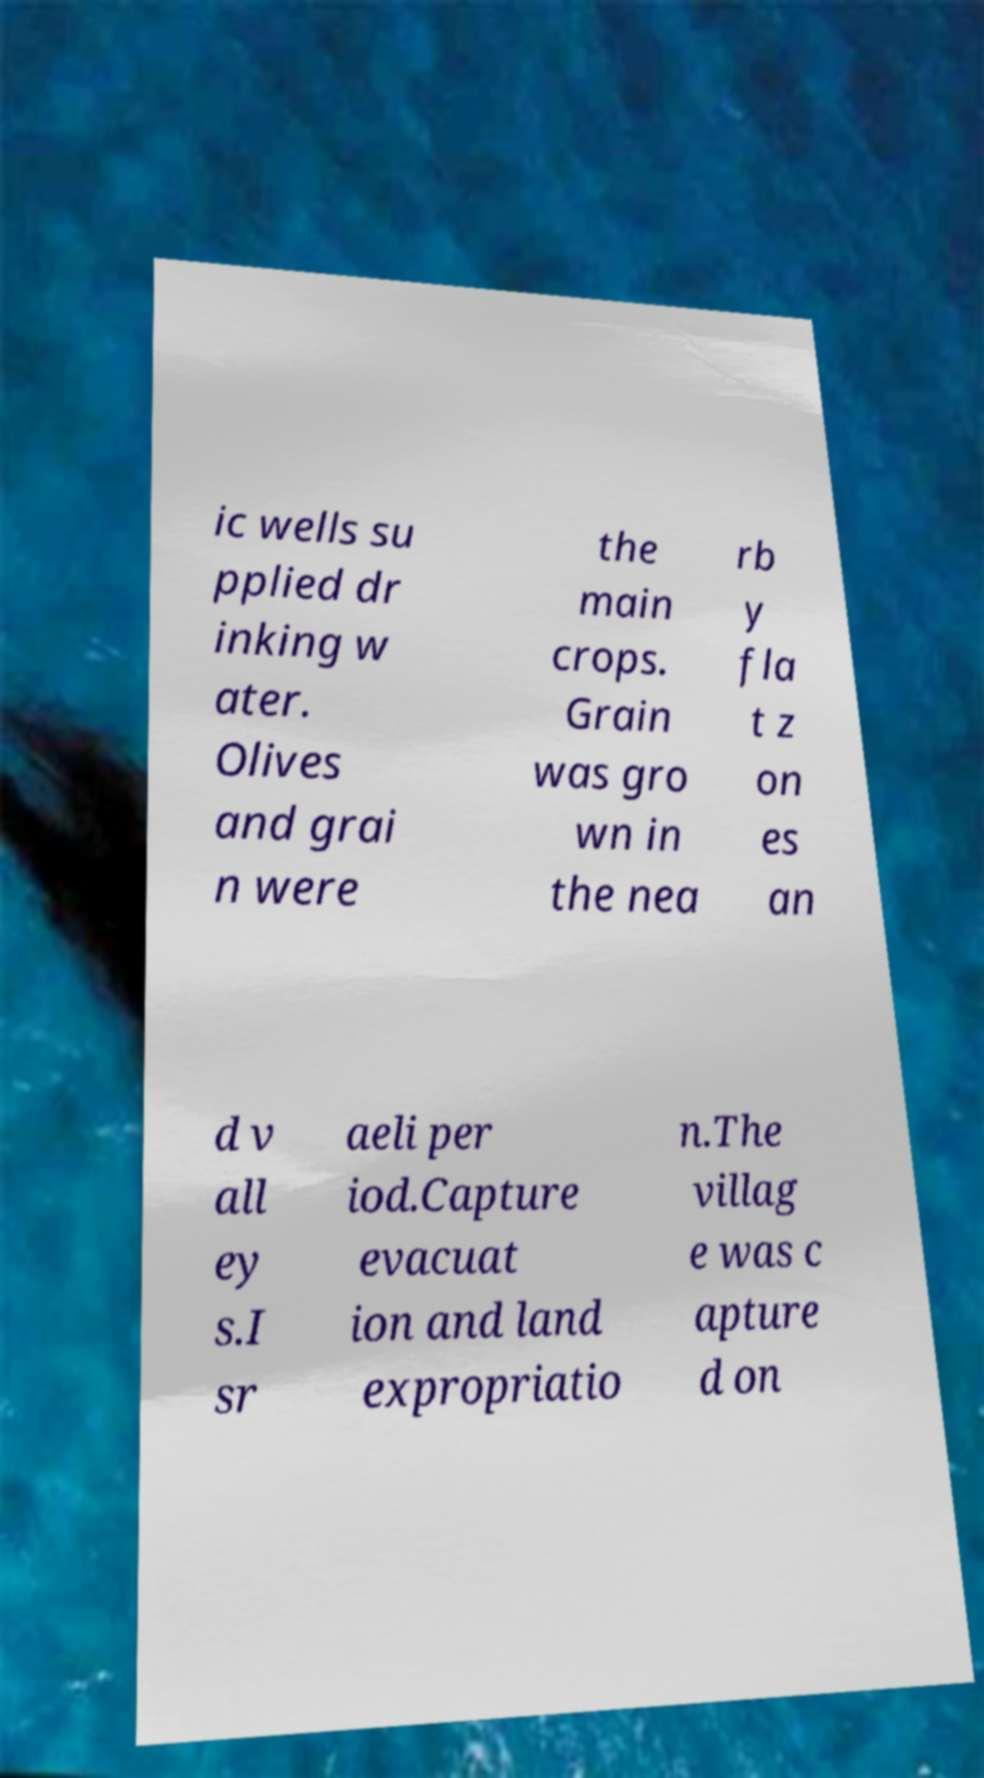Can you read and provide the text displayed in the image?This photo seems to have some interesting text. Can you extract and type it out for me? ic wells su pplied dr inking w ater. Olives and grai n were the main crops. Grain was gro wn in the nea rb y fla t z on es an d v all ey s.I sr aeli per iod.Capture evacuat ion and land expropriatio n.The villag e was c apture d on 